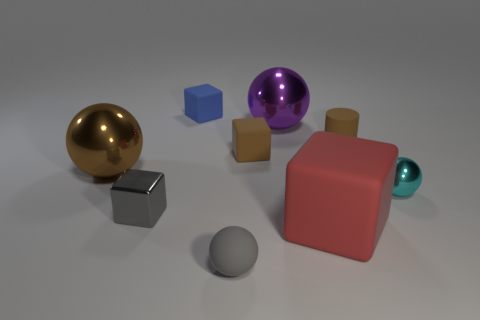Is the number of tiny blue rubber cubes that are on the right side of the small gray ball greater than the number of large red blocks?
Give a very brief answer. No. How many other things are there of the same color as the small cylinder?
Offer a terse response. 2. The blue thing that is the same size as the cyan thing is what shape?
Your answer should be compact. Cube. There is a sphere that is right of the large ball that is to the right of the small blue matte cube; how many brown metallic spheres are in front of it?
Offer a terse response. 0. How many rubber objects are tiny cyan objects or tiny brown blocks?
Your answer should be very brief. 1. There is a cube that is both right of the tiny blue matte cube and in front of the small metallic ball; what is its color?
Make the answer very short. Red. There is a brown object on the left side of the gray metal block; does it have the same size as the small gray sphere?
Keep it short and to the point. No. What number of things are either blocks that are on the right side of the tiny gray shiny cube or metal cylinders?
Offer a very short reply. 3. Is there a gray rubber cylinder of the same size as the gray shiny thing?
Make the answer very short. No. There is a cylinder that is the same size as the cyan metallic thing; what material is it?
Keep it short and to the point. Rubber. 